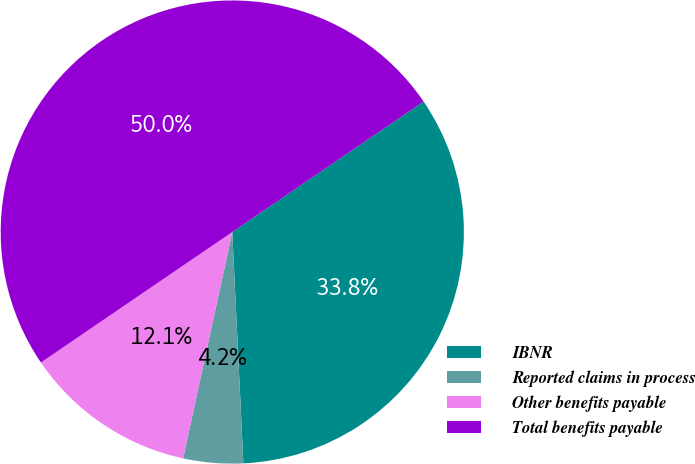<chart> <loc_0><loc_0><loc_500><loc_500><pie_chart><fcel>IBNR<fcel>Reported claims in process<fcel>Other benefits payable<fcel>Total benefits payable<nl><fcel>33.77%<fcel>4.17%<fcel>12.07%<fcel>50.0%<nl></chart> 